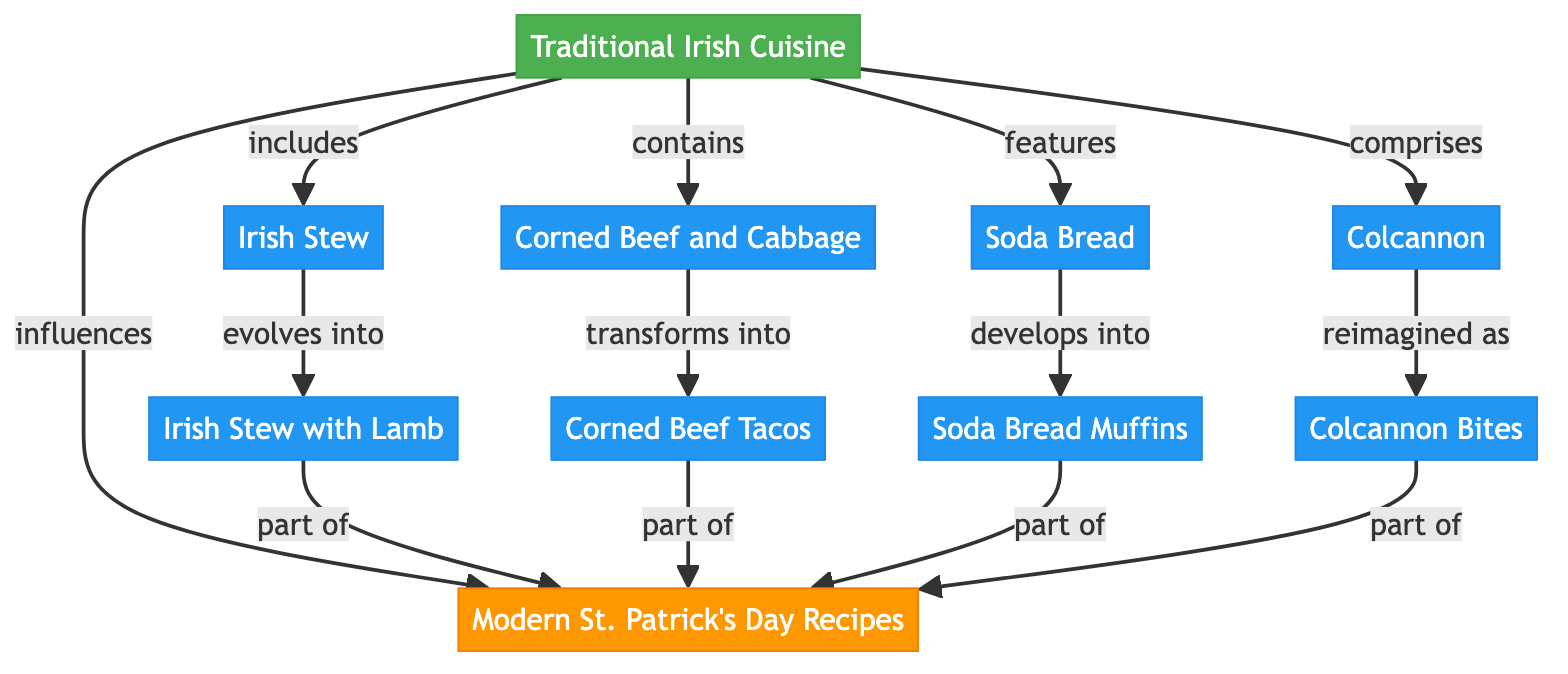What are the four types of traditional Irish dishes shown in the diagram? The diagram lists four traditional Irish dishes: Irish Stew, Corned Beef and Cabbage, Soda Bread, and Colcannon. These are directly indicated under the "Traditional Irish Cuisine" node.
Answer: Irish Stew, Corned Beef and Cabbage, Soda Bread, Colcannon How many modern St. Patrick's Day recipes are mentioned in the diagram? The diagram shows four modern St. Patrick's Day recipes: Irish Stew with Lamb, Corned Beef Tacos, Soda Bread Muffins, and Colcannon Bites. Thus, there are four recipes listed under the "Modern St. Patrick's Day Recipes" node.
Answer: 4 What does Irish Stew evolve into according to the diagram? The diagram indicates that Irish Stew evolves into Irish Stew with Lamb, as shown by the arrow connecting these two nodes.
Answer: Irish Stew with Lamb What is the relationship between Corned Beef and Cabbage and Corned Beef Tacos? The diagram illustrates that Corned Beef and Cabbage transforms into Corned Beef Tacos, which is represented by the directed relationship indicating their connection in the evolution from traditional to modern cuisine.
Answer: transforms into Which traditional dish does Soda Bread develop into? The diagram shows that Soda Bread develops into Soda Bread Muffins, depicted by the directed edge linking these two dishes.
Answer: Soda Bread Muffins What type of diagram is being represented? The diagram is a Social Science Diagram, as it illustrates the influence of traditional Irish cuisine on modern St. Patrick's Day recipes through relationships and transformations between dishes.
Answer: Social Science Diagram Which dish is both a traditional dish and a modern recipe in the diagram? The diagram indicates that Irish Stew's evolution is reflected in the modern recipe Irish Stew with Lamb, making it the dish that connects traditional and modern contexts.
Answer: Irish Stew How many dishes are influenced by the traditional Irish cuisine in total? Counting all the traditional dishes that have transformations or evolutions shown in the diagram, we have four traditional dishes and each has a modern counterpart, leading to a total of eight dishes influenced.
Answer: 8 